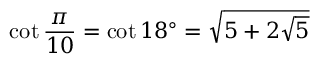Convert formula to latex. <formula><loc_0><loc_0><loc_500><loc_500>\cot { \frac { \pi } { 1 0 } } = \cot 1 8 ^ { \circ } = { \sqrt { 5 + 2 { \sqrt { 5 } } } }</formula> 